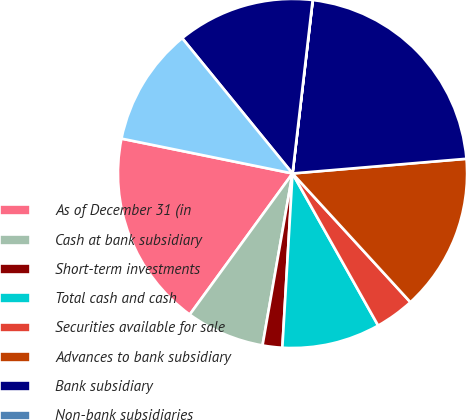Convert chart to OTSL. <chart><loc_0><loc_0><loc_500><loc_500><pie_chart><fcel>As of December 31 (in<fcel>Cash at bank subsidiary<fcel>Short-term investments<fcel>Total cash and cash<fcel>Securities available for sale<fcel>Advances to bank subsidiary<fcel>Bank subsidiary<fcel>Non-bank subsidiaries<fcel>Goodwill<fcel>Other assets<nl><fcel>18.18%<fcel>7.27%<fcel>1.82%<fcel>9.09%<fcel>3.64%<fcel>14.54%<fcel>21.81%<fcel>0.01%<fcel>12.73%<fcel>10.91%<nl></chart> 